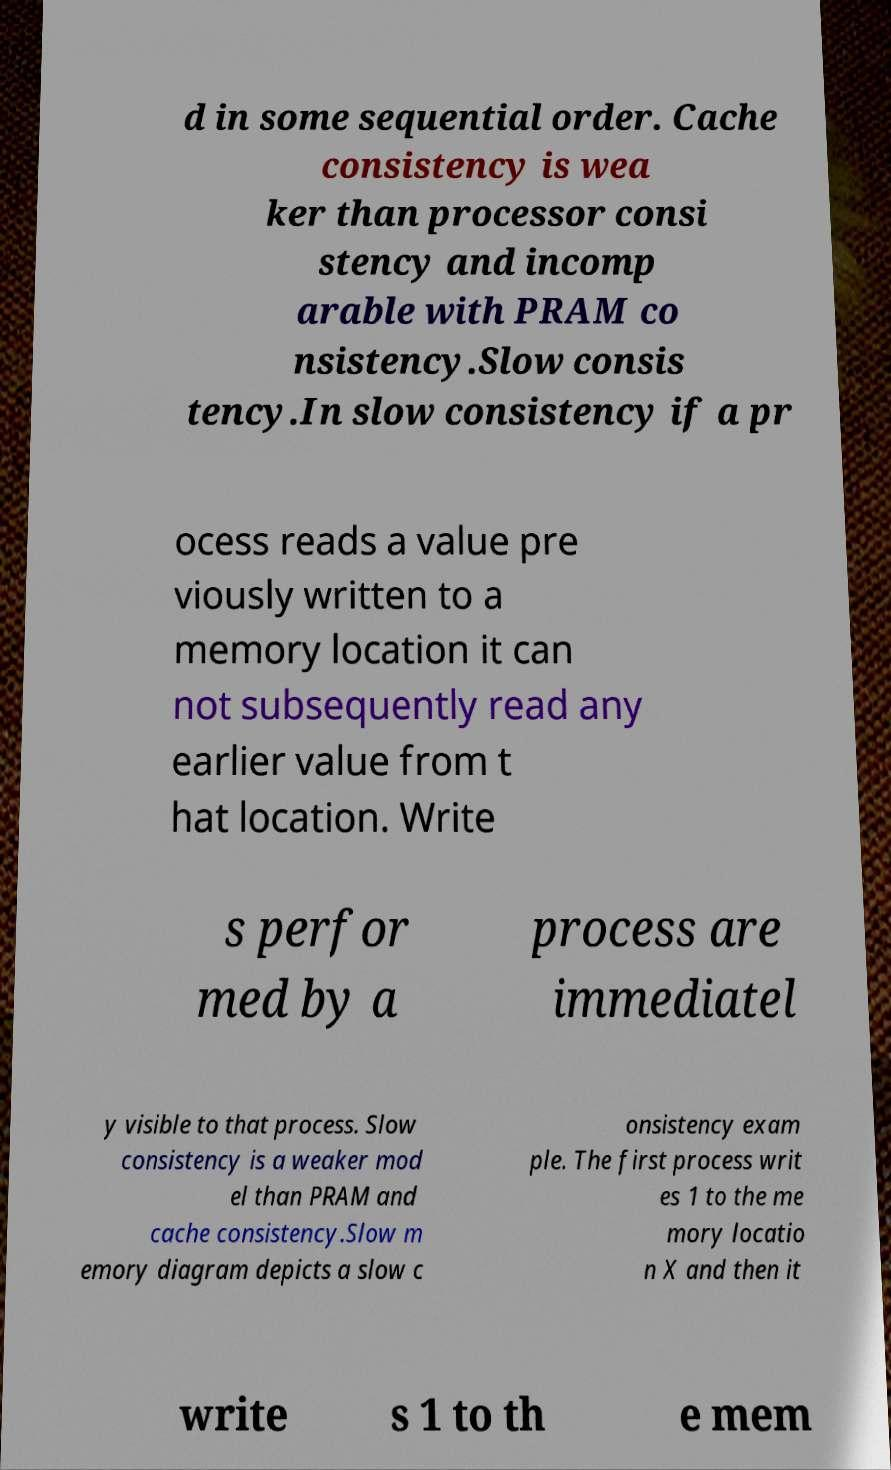Can you read and provide the text displayed in the image?This photo seems to have some interesting text. Can you extract and type it out for me? d in some sequential order. Cache consistency is wea ker than processor consi stency and incomp arable with PRAM co nsistency.Slow consis tency.In slow consistency if a pr ocess reads a value pre viously written to a memory location it can not subsequently read any earlier value from t hat location. Write s perfor med by a process are immediatel y visible to that process. Slow consistency is a weaker mod el than PRAM and cache consistency.Slow m emory diagram depicts a slow c onsistency exam ple. The first process writ es 1 to the me mory locatio n X and then it write s 1 to th e mem 